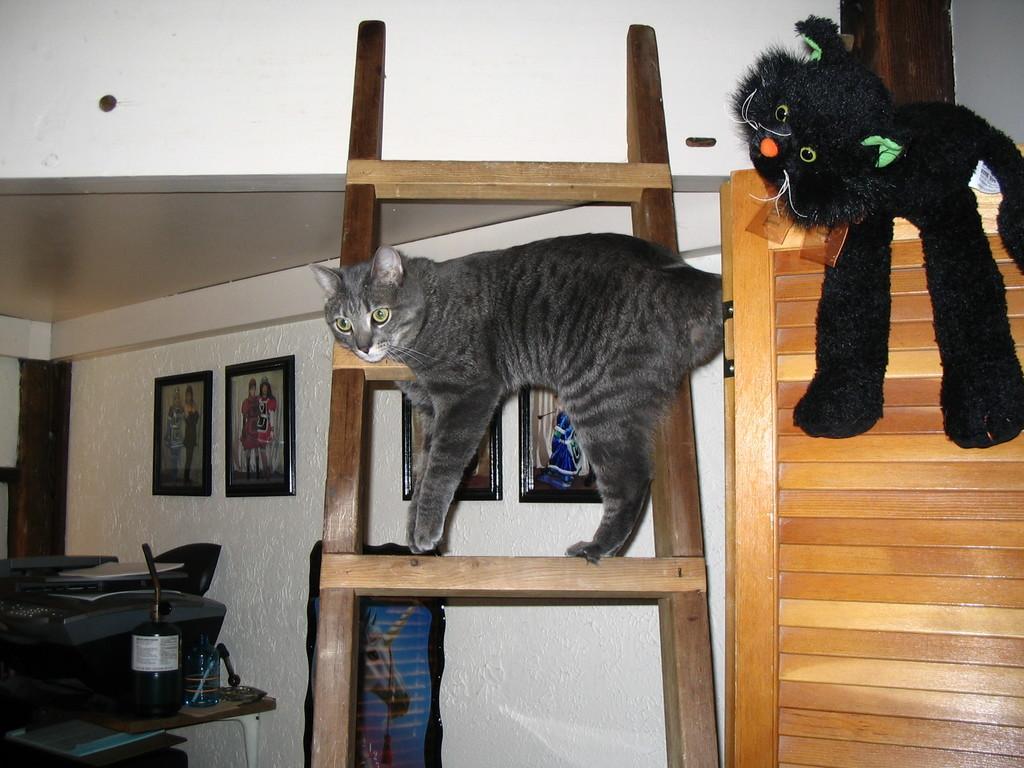Can you describe this image briefly? In this image we can see a cat on a ladder, there is a toy on a wooden object, there is a wall and photo frames on it, there is a table, bottle and some objects on it. 